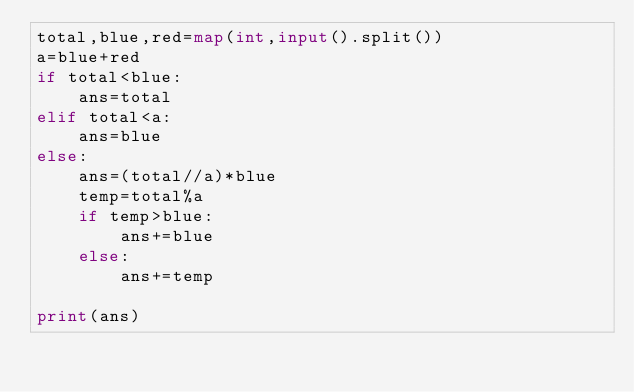<code> <loc_0><loc_0><loc_500><loc_500><_Python_>total,blue,red=map(int,input().split())
a=blue+red
if total<blue:
    ans=total
elif total<a:
    ans=blue
else:
    ans=(total//a)*blue
    temp=total%a
    if temp>blue:
        ans+=blue
    else:
        ans+=temp

print(ans)</code> 